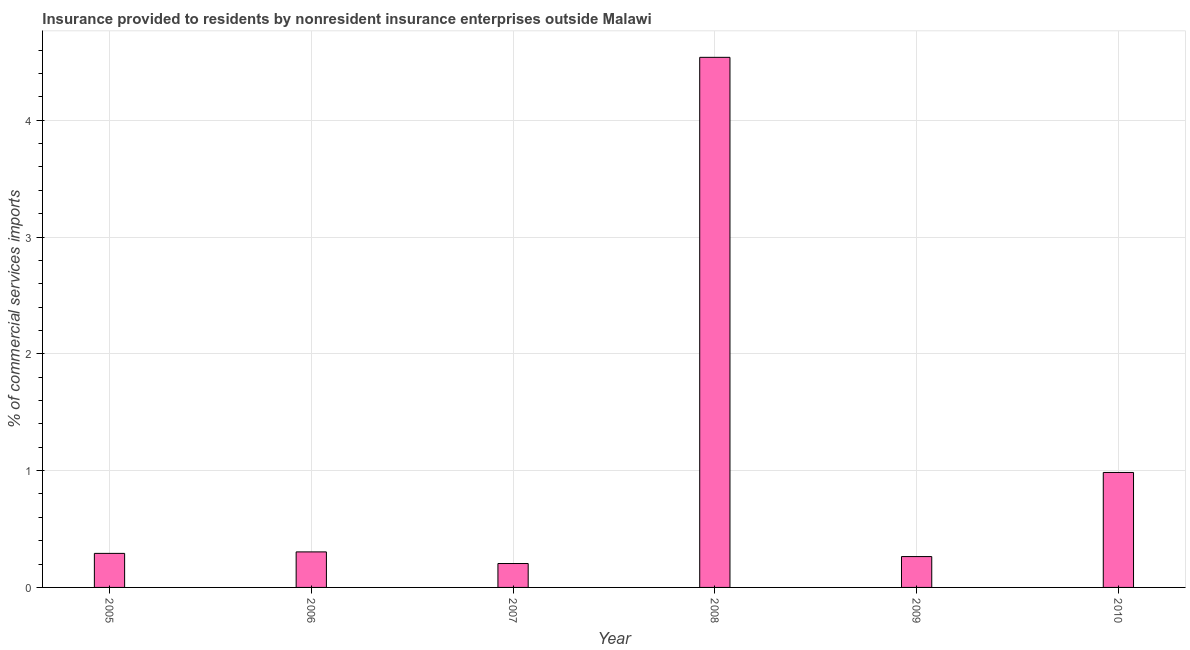What is the title of the graph?
Your answer should be very brief. Insurance provided to residents by nonresident insurance enterprises outside Malawi. What is the label or title of the X-axis?
Ensure brevity in your answer.  Year. What is the label or title of the Y-axis?
Ensure brevity in your answer.  % of commercial services imports. What is the insurance provided by non-residents in 2008?
Provide a succinct answer. 4.54. Across all years, what is the maximum insurance provided by non-residents?
Your answer should be very brief. 4.54. Across all years, what is the minimum insurance provided by non-residents?
Your response must be concise. 0.2. In which year was the insurance provided by non-residents maximum?
Provide a short and direct response. 2008. What is the sum of the insurance provided by non-residents?
Provide a succinct answer. 6.59. What is the difference between the insurance provided by non-residents in 2009 and 2010?
Offer a terse response. -0.72. What is the average insurance provided by non-residents per year?
Your answer should be very brief. 1.1. What is the median insurance provided by non-residents?
Your response must be concise. 0.3. What is the ratio of the insurance provided by non-residents in 2008 to that in 2009?
Ensure brevity in your answer.  17.18. Is the insurance provided by non-residents in 2006 less than that in 2010?
Keep it short and to the point. Yes. Is the difference between the insurance provided by non-residents in 2009 and 2010 greater than the difference between any two years?
Keep it short and to the point. No. What is the difference between the highest and the second highest insurance provided by non-residents?
Provide a short and direct response. 3.55. What is the difference between the highest and the lowest insurance provided by non-residents?
Provide a short and direct response. 4.33. In how many years, is the insurance provided by non-residents greater than the average insurance provided by non-residents taken over all years?
Keep it short and to the point. 1. How many bars are there?
Give a very brief answer. 6. Are all the bars in the graph horizontal?
Make the answer very short. No. What is the difference between two consecutive major ticks on the Y-axis?
Offer a very short reply. 1. Are the values on the major ticks of Y-axis written in scientific E-notation?
Offer a terse response. No. What is the % of commercial services imports in 2005?
Offer a terse response. 0.29. What is the % of commercial services imports of 2006?
Your answer should be very brief. 0.3. What is the % of commercial services imports in 2007?
Your answer should be very brief. 0.2. What is the % of commercial services imports in 2008?
Your response must be concise. 4.54. What is the % of commercial services imports in 2009?
Provide a succinct answer. 0.26. What is the % of commercial services imports of 2010?
Your answer should be very brief. 0.98. What is the difference between the % of commercial services imports in 2005 and 2006?
Offer a terse response. -0.01. What is the difference between the % of commercial services imports in 2005 and 2007?
Provide a short and direct response. 0.09. What is the difference between the % of commercial services imports in 2005 and 2008?
Provide a succinct answer. -4.25. What is the difference between the % of commercial services imports in 2005 and 2009?
Make the answer very short. 0.03. What is the difference between the % of commercial services imports in 2005 and 2010?
Your answer should be very brief. -0.69. What is the difference between the % of commercial services imports in 2006 and 2007?
Your response must be concise. 0.1. What is the difference between the % of commercial services imports in 2006 and 2008?
Offer a very short reply. -4.23. What is the difference between the % of commercial services imports in 2006 and 2009?
Your answer should be compact. 0.04. What is the difference between the % of commercial services imports in 2006 and 2010?
Your response must be concise. -0.68. What is the difference between the % of commercial services imports in 2007 and 2008?
Your answer should be compact. -4.33. What is the difference between the % of commercial services imports in 2007 and 2009?
Your response must be concise. -0.06. What is the difference between the % of commercial services imports in 2007 and 2010?
Ensure brevity in your answer.  -0.78. What is the difference between the % of commercial services imports in 2008 and 2009?
Your answer should be compact. 4.27. What is the difference between the % of commercial services imports in 2008 and 2010?
Offer a terse response. 3.55. What is the difference between the % of commercial services imports in 2009 and 2010?
Offer a terse response. -0.72. What is the ratio of the % of commercial services imports in 2005 to that in 2006?
Your answer should be compact. 0.96. What is the ratio of the % of commercial services imports in 2005 to that in 2007?
Make the answer very short. 1.42. What is the ratio of the % of commercial services imports in 2005 to that in 2008?
Offer a very short reply. 0.06. What is the ratio of the % of commercial services imports in 2005 to that in 2009?
Your answer should be compact. 1.1. What is the ratio of the % of commercial services imports in 2005 to that in 2010?
Keep it short and to the point. 0.3. What is the ratio of the % of commercial services imports in 2006 to that in 2007?
Offer a very short reply. 1.49. What is the ratio of the % of commercial services imports in 2006 to that in 2008?
Provide a succinct answer. 0.07. What is the ratio of the % of commercial services imports in 2006 to that in 2009?
Provide a succinct answer. 1.15. What is the ratio of the % of commercial services imports in 2006 to that in 2010?
Keep it short and to the point. 0.31. What is the ratio of the % of commercial services imports in 2007 to that in 2008?
Give a very brief answer. 0.04. What is the ratio of the % of commercial services imports in 2007 to that in 2009?
Your answer should be compact. 0.78. What is the ratio of the % of commercial services imports in 2007 to that in 2010?
Provide a short and direct response. 0.21. What is the ratio of the % of commercial services imports in 2008 to that in 2009?
Your answer should be compact. 17.18. What is the ratio of the % of commercial services imports in 2008 to that in 2010?
Your response must be concise. 4.61. What is the ratio of the % of commercial services imports in 2009 to that in 2010?
Ensure brevity in your answer.  0.27. 